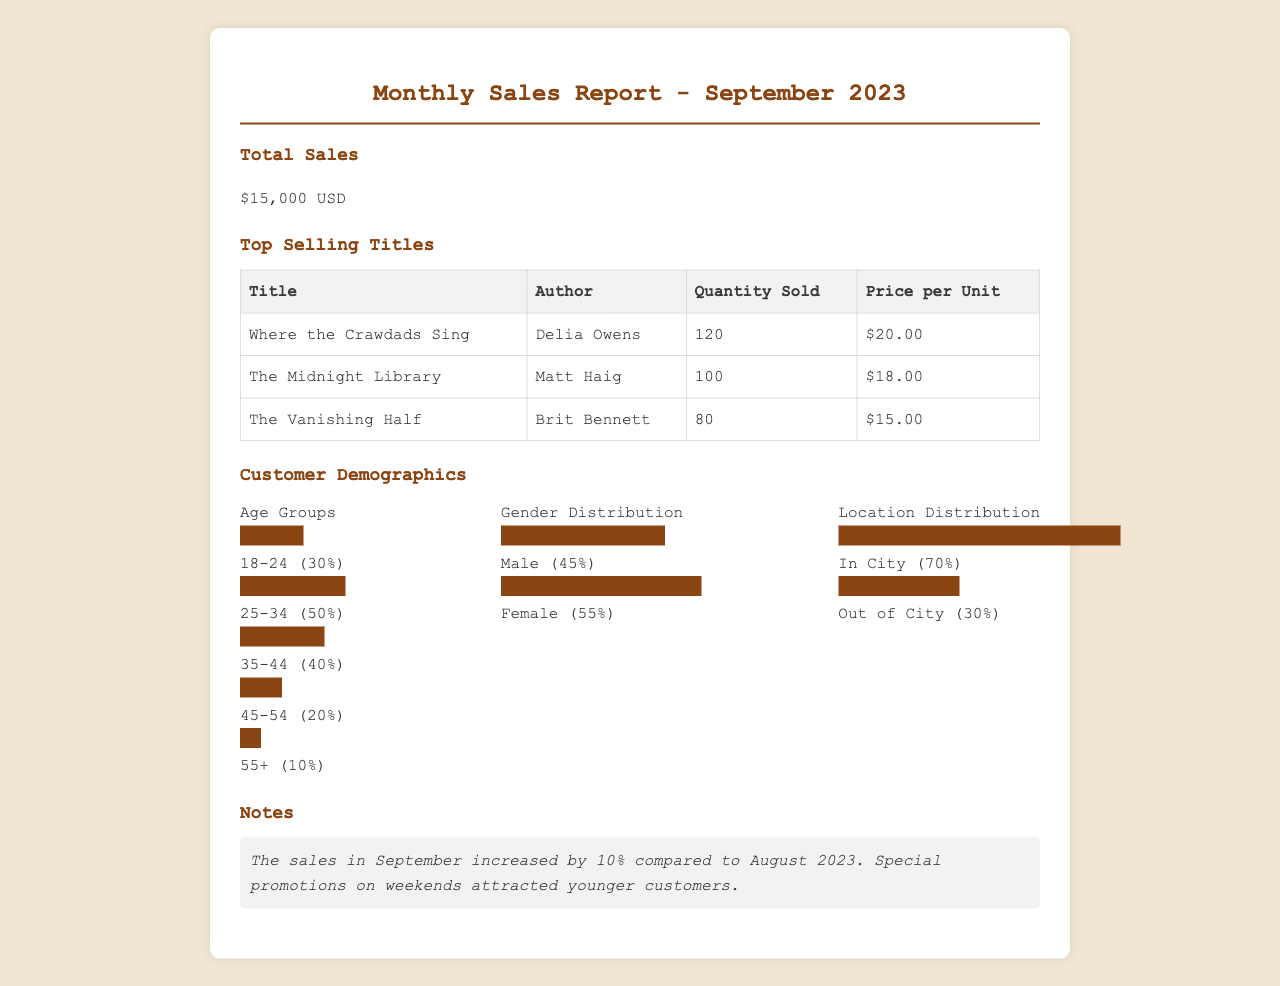What is the total sales amount for September 2023? The document specifies that the total sales amount is listed under the "Total Sales" section.
Answer: $15,000 USD What is the top-selling title in September 2023? The document provides a table under "Top Selling Titles" that lists titles and their quantities sold.
Answer: Where the Crawdads Sing How many copies of "The Midnight Library" were sold? The quantity sold for "The Midnight Library" is found in the table under the "Top Selling Titles" section.
Answer: 100 What percentage of customers were aged 25-34? The age groups' distribution is detailed in the "Customer Demographics" section of the report.
Answer: 50% How many customers were identified as male? The gender distribution section indicates the percentage of male customers among the total.
Answer: 45% What was the increase in sales compared to August 2023? The notes section mentions a percentage increase in sales from the previous month.
Answer: 10% What percentage of customers are located in the city? The location distribution section specifies the percentage of customers from within the city.
Answer: 70% Who is the author of "The Vanishing Half"? The author is listed in the "Top Selling Titles" table alongside the title.
Answer: Brit Bennett What does the notes section indicate about the customer trend in September? The notes section discusses the influence of special promotions on customer demographics.
Answer: Special promotions attracted younger customers 